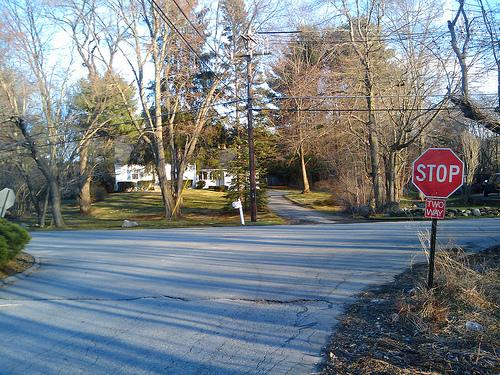Mention the prominent features of the street as depicted in the image. The street features a stop sign, a two-way sign, mailboxes, bare trees, a power pole, a driveway, and a crack in the road. Describe the material on which the road is made. The road is made of concrete. What kind of structure can be found in front of the house? There is a power pole in the front yard of the house. In an informal voice, describe what you see happening around the intersection. So there's this intersection with a stop sign and a two-way sign, right? And like, there are these mailboxes and bare trees all around, plus a power pole and a driveway. Oh, and the road has a crack in it! What is unique about the "two signs" mentioned in the image descriptions? The unique aspect is that the two signs are both on one pole. What does the primary street sign in the image say? The primary street sign says "stop" as it is a red stop sign. Mention the color and type of the house near the trees. The house near the trees is a white home in a wooded area. Summarize the main elements of the scene in a single sentence. The scene captures a street intersection with a stop sign, a two-way sign, a white house, bare trees, mailboxes, a power pole, a driveway, and a cracked concrete road. If you were to rate the general condition of the street, would you say it is well-maintained or damaged? Justify your answer. I'd say the street is damaged, primarily because there is a crack in the road and some trash on the ground. Describe the condition of the trees in the image. The trees in the image are bare, indicating they are missing their leaves. Is there a blue mailbox floating in mid-air at the edge of the driveway? The described mailboxes in the image are white and residential, without any mention of being blue or floating. They also are not associated with the edge of the driveway but are closer to the road. What other object shares the same pole with the stop sign at X:417 Y:140? A two-way sign. Are there any animals on the rock wall along the wall? There is no mention of any animals in the image information. The rock wall is mentioned, but without any reference to an animal being present. Assess the quality of the image. The image quality is good. What type of vehicle can be seen in the driveway? There is no vehicle in the driveway. List the sign(s) that is on the side of the road at X:260 Y:93. A stop sign and a two-way sign. Find the position and size of the mailbox in the image. X:231 Y:195 Width:16 Height:16 Is there a large, lush palm tree growing in the middle of the street? In this image, there are multiple instances of trees being mentioned, but they're mostly described as bare and growing across the street. There is no mention of a palm tree or any tree growing specifically in the middle of the street. What is the color of the house beyond the trees? White. Are there any visible electric lines in the image? Yes, electric lines are above the street. Can you see a car parked in the driveway near the telephone pole? In this image, there's no mention of a car parked in the driveway or near a telephone pole. The telephone pole and driveway are described separately, but there's no link to any car. Is there a large picnic table in front of the house beyond the trees? The provided image information depicts a house beyond the trees, but there's no mention of a picnic table or any object in front of the house. What is the main scene in the image? A street intersection scene. Which object is closer to the street crack, a bush or a house? A bush is growing on the corner. What is the location and dimensions of one of the larger tree branches in the image? X:447 Y:23 Width:51 Height:51 Identify the color and type of sign at coordinates X:411 Y:145. It is a red stop sign. Please perform OCR on the words written on the sign at X:414 Y:158. STOP What are the Width and Height dimensions for the large tree at X:269 Y:53? Width:46 Height:46 Describe any anomalies detected in the image. A crack in the street. What material is the road made from? Concrete Enumerate the different types of signs present in the image. Stop signs, two-way signs. What is present in the front yard of the house? Power pole and trees. Is the stop sign green and situated at the top left corner of the image? There are numerous mentions of a stop sign, however, none of them indicate it being green or situated at the top left corner. Customarily, stop signs are red, which is how they're mentioned in the given image. What type of mailbox is located near the road? White mail box. Determine if the trees in the image have leaves or not. The trees are bare. Evaluate the sentiment of the image. Neutral sentiment. 